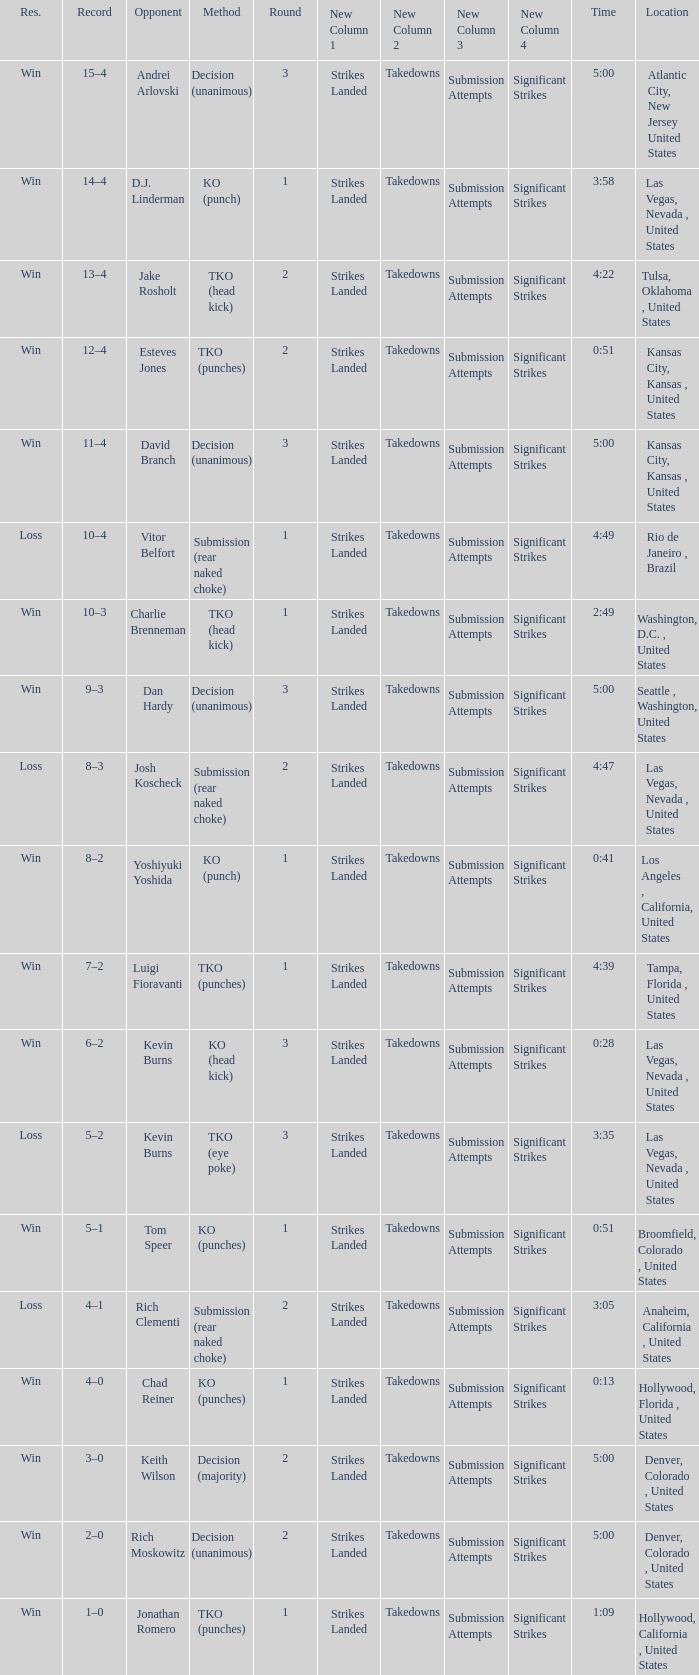What is the highest round number with a time of 4:39? 1.0. 